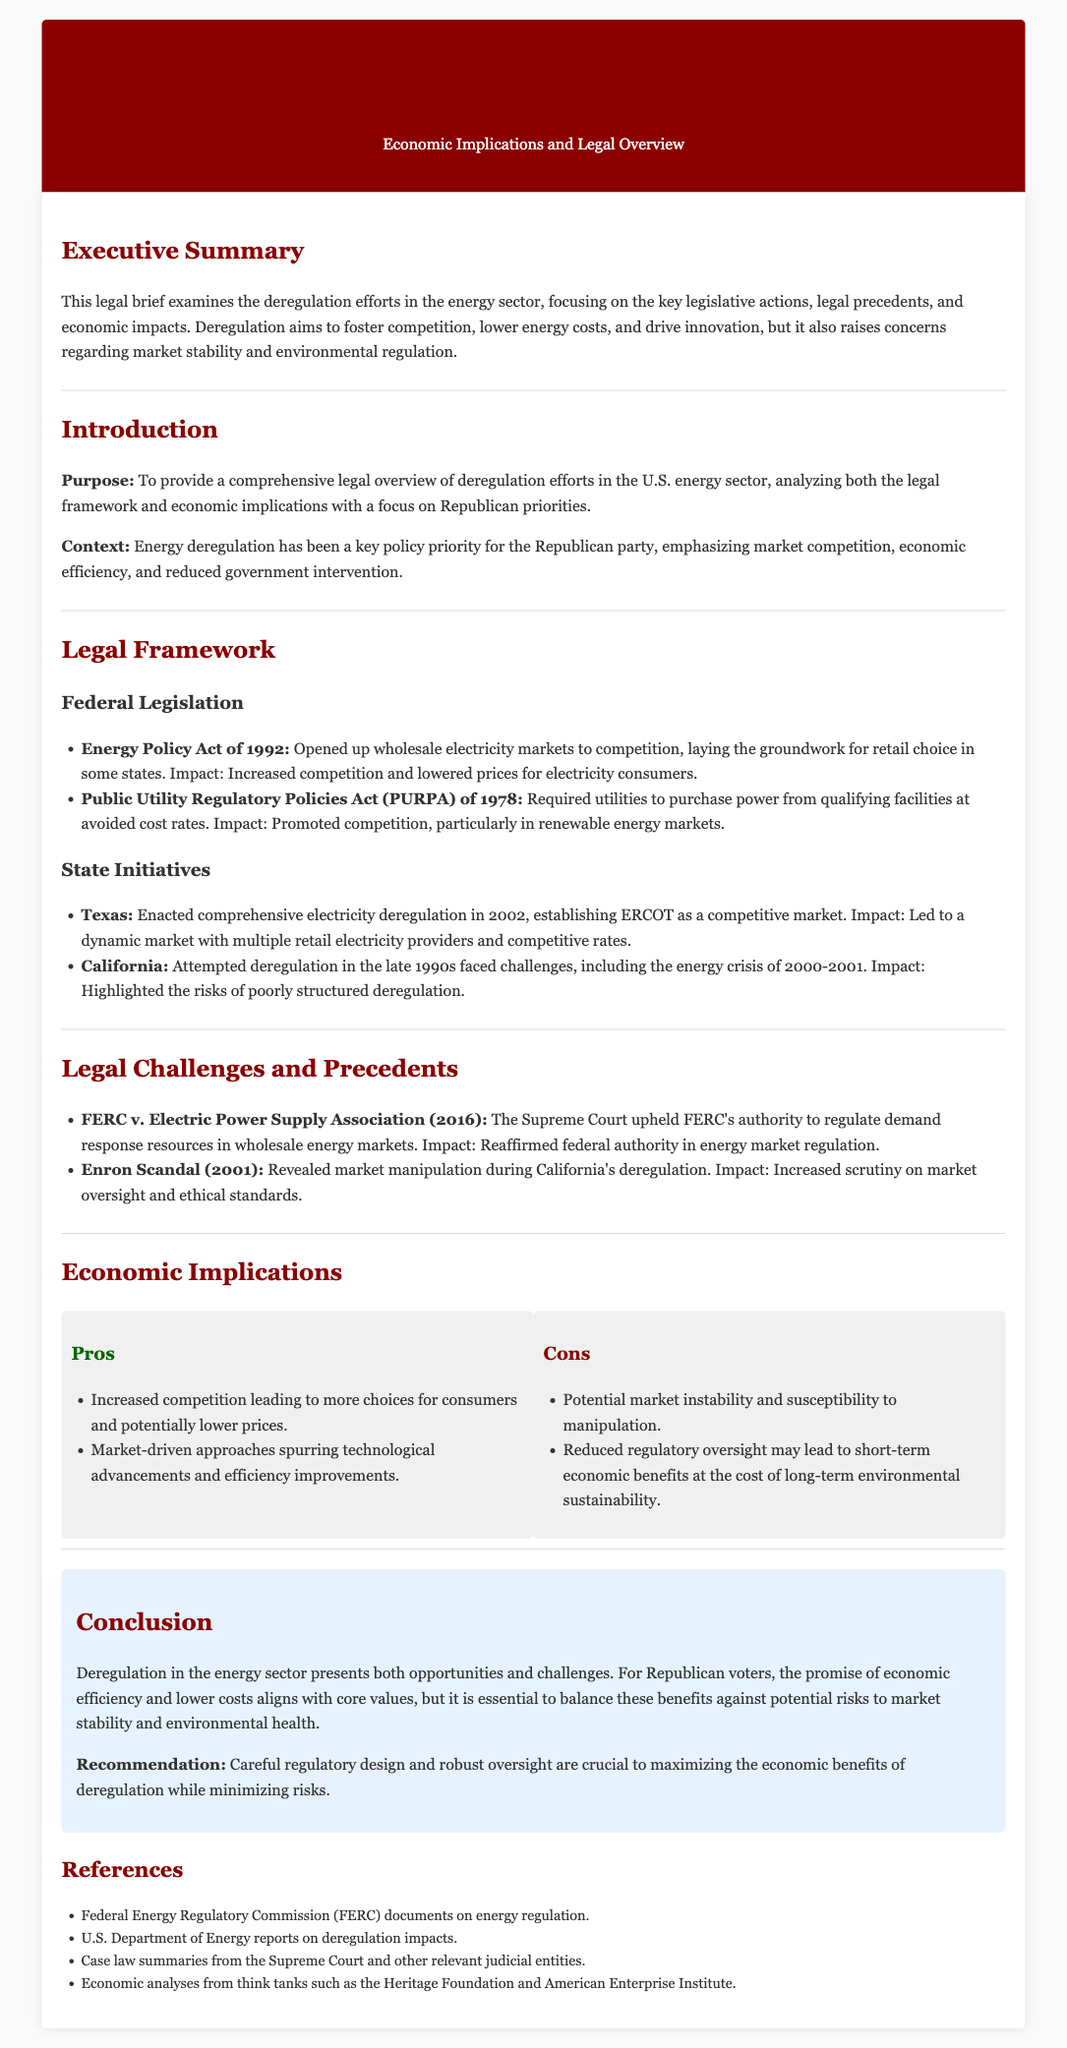what is the title of the legal brief? The title is explicitly stated in the header of the document.
Answer: Legal Brief: Energy Sector Deregulation what year was the Energy Policy Act enacted? The document specifies the year of the Energy Policy Act in the legal framework section.
Answer: 1992 which state enacted comprehensive electricity deregulation in 2002? The document mentions Texas in the context of state initiatives under the legal framework section.
Answer: Texas what legal case reaffirmed federal authority in energy market regulation? The document lists a specific Supreme Court case in the legal challenges section.
Answer: FERC v. Electric Power Supply Association what is one potential con of deregulation mentioned? The cons of deregulation are detailed in the economic implications section.
Answer: Market instability how many pros of deregulation are listed? The document enumerates the pros in the pros-cons section.
Answer: Two what is the recommended approach for maximizing the economic benefits of deregulation? The conclusion mentions a specific recommendation related to regulatory design and oversight.
Answer: Careful regulatory design what does the Republican party emphasize in energy deregulation efforts? The introduction outlines the Republican priorities in energy policy.
Answer: Market competition what is one economic impact of the Energy Policy Act? The document describes the impacts in the legal framework section regarding the Energy Policy Act.
Answer: Lowered prices for electricity consumers 